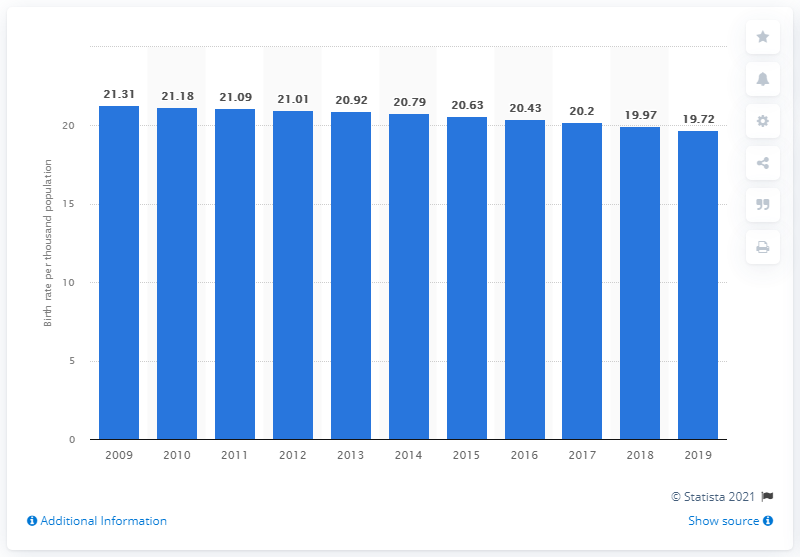Identify some key points in this picture. The crude birth rate in Guyana in 2019 was 19.72 births per 1,000 people. 